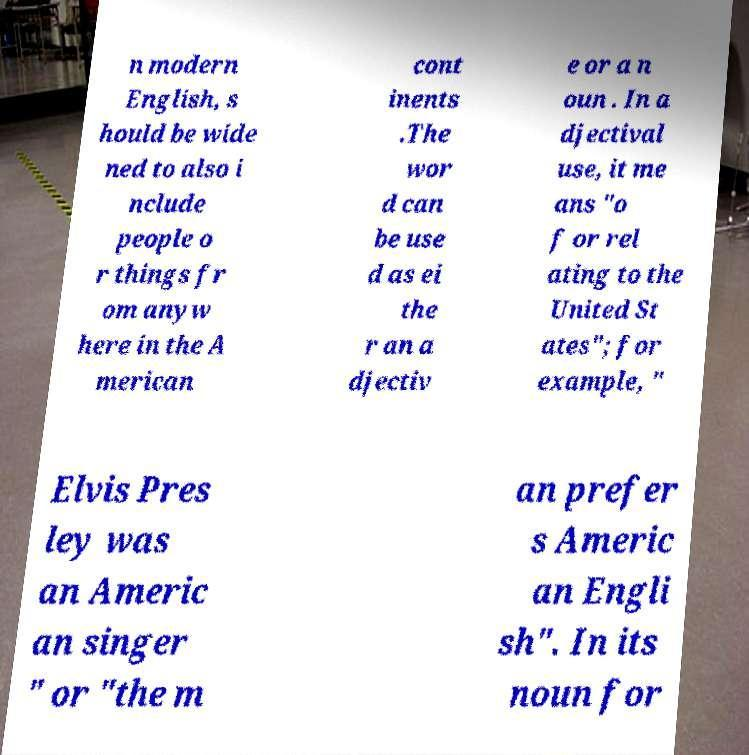What messages or text are displayed in this image? I need them in a readable, typed format. n modern English, s hould be wide ned to also i nclude people o r things fr om anyw here in the A merican cont inents .The wor d can be use d as ei the r an a djectiv e or a n oun . In a djectival use, it me ans "o f or rel ating to the United St ates"; for example, " Elvis Pres ley was an Americ an singer " or "the m an prefer s Americ an Engli sh". In its noun for 